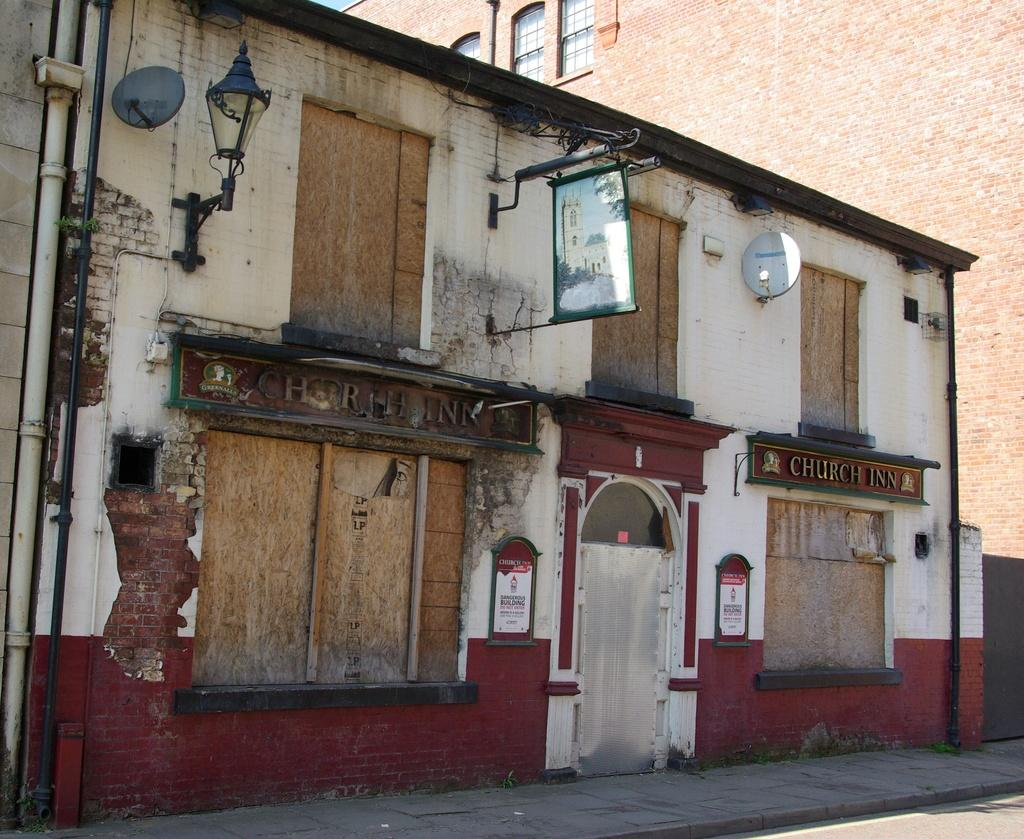What type of building is in the image? The building in the image has red bricks. Are there any specific features on the building? Yes, there is a lamp and a banner on the building. What is in front of the building? There is a road in front of the building. How many flowers are growing on the building in the image? There are no flowers visible on the building in the image. What type of addition problem can be solved using the numbers on the banner? The banner in the image does not display any numbers, so it cannot be used to solve an addition problem. 